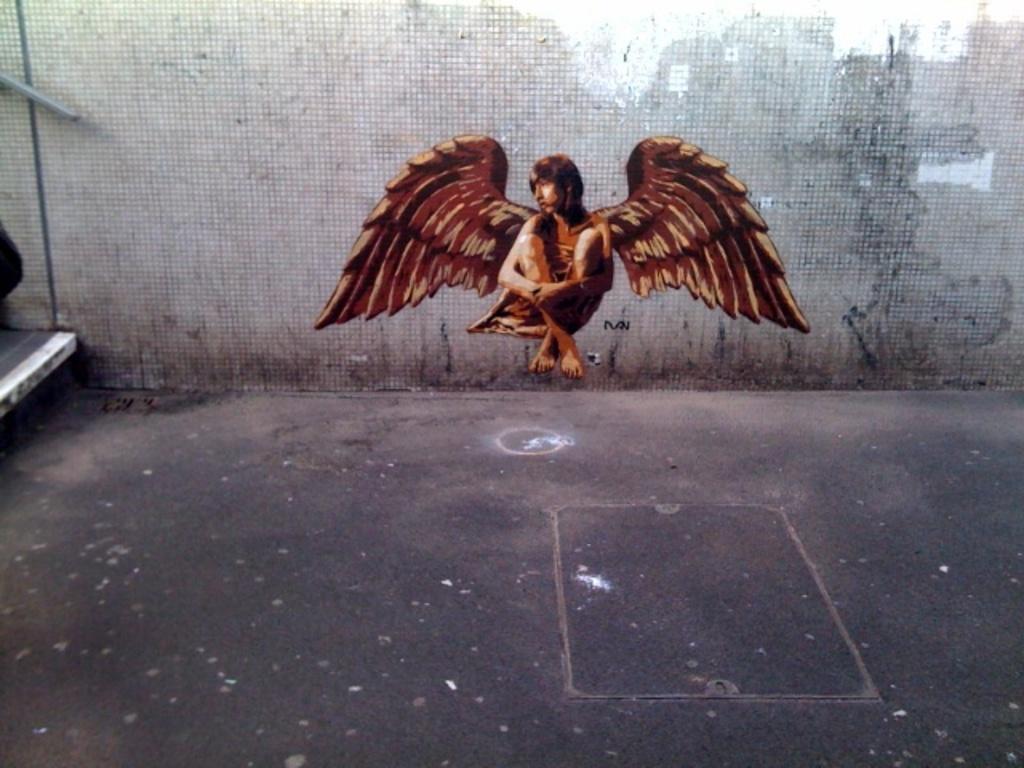Describe this image in one or two sentences. As we can see in the image is an animation of a woman. The woman has wings and there is a wall. 